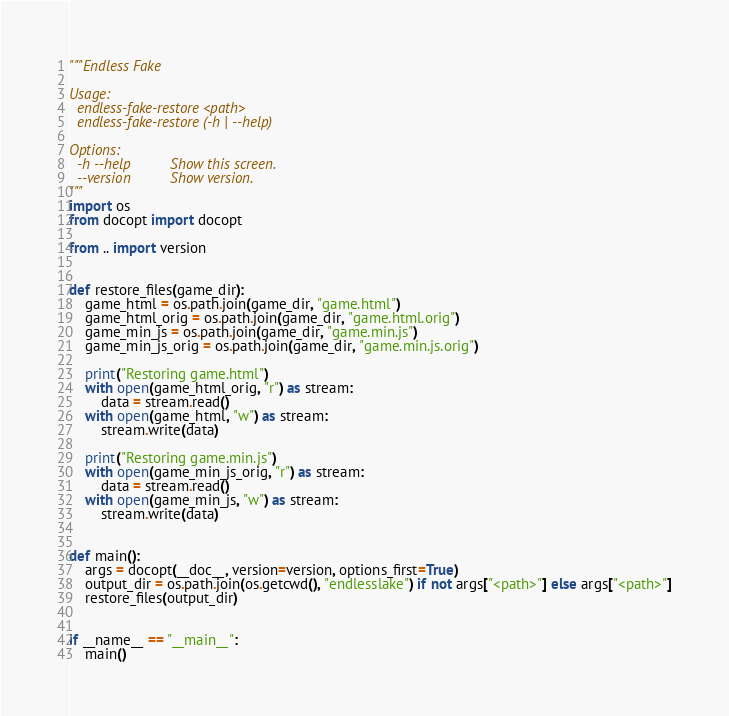<code> <loc_0><loc_0><loc_500><loc_500><_Python_>"""Endless Fake

Usage:
  endless-fake-restore <path>
  endless-fake-restore (-h | --help)

Options:
  -h --help          Show this screen.
  --version          Show version.
"""
import os
from docopt import docopt

from .. import version


def restore_files(game_dir):
    game_html = os.path.join(game_dir, "game.html")
    game_html_orig = os.path.join(game_dir, "game.html.orig")
    game_min_js = os.path.join(game_dir, "game.min.js")
    game_min_js_orig = os.path.join(game_dir, "game.min.js.orig")

    print("Restoring game.html")
    with open(game_html_orig, "r") as stream:
        data = stream.read()
    with open(game_html, "w") as stream:
        stream.write(data)

    print("Restoring game.min.js")
    with open(game_min_js_orig, "r") as stream:
        data = stream.read()
    with open(game_min_js, "w") as stream:
        stream.write(data)


def main():
    args = docopt(__doc__, version=version, options_first=True)
    output_dir = os.path.join(os.getcwd(), "endlesslake") if not args["<path>"] else args["<path>"]
    restore_files(output_dir)


if __name__ == "__main__":
    main()
</code> 